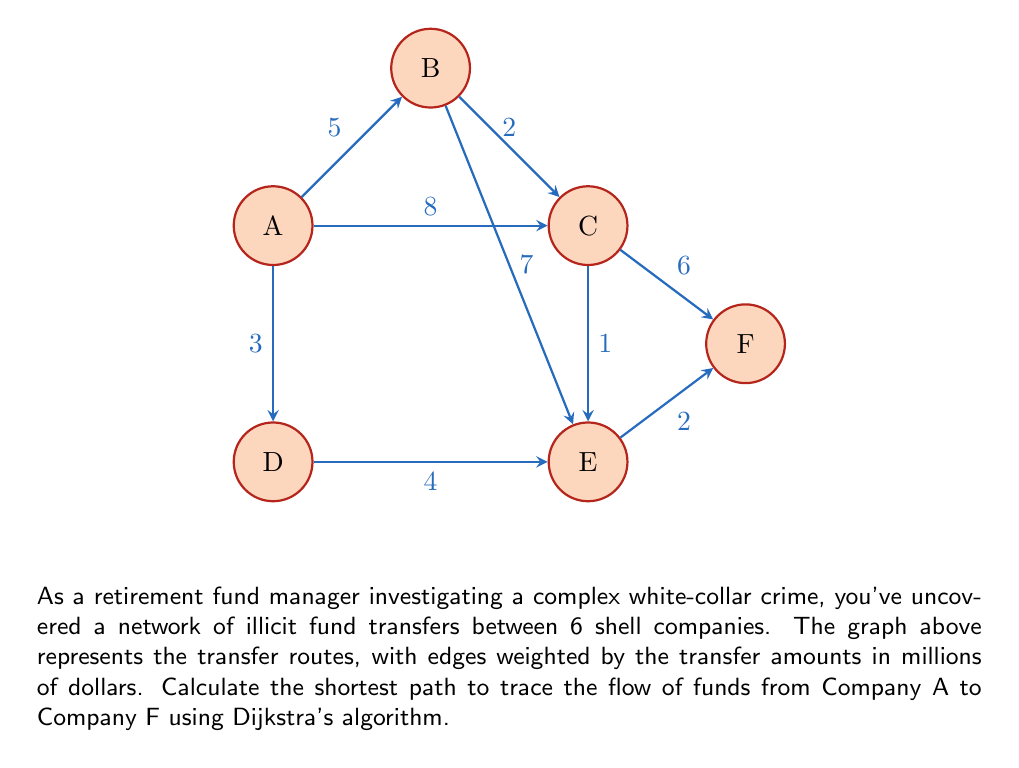Show me your answer to this math problem. To solve this problem, we'll use Dijkstra's algorithm to find the shortest path from Company A to Company F. Here's the step-by-step process:

1) Initialize:
   - Set distance to A as 0, and all others as infinity.
   - Set all nodes as unvisited.
   - Set A as the current node.

2) For the current node, calculate the distance to all unvisited neighbors:
   - A to B: 0 + 5 = 5
   - A to C: 0 + 8 = 8
   - A to D: 0 + 3 = 3

3) Update distances if shorter path found. Mark A as visited.

4) Select the unvisited node with the smallest distance (D) as the new current node.

5) Repeat steps 2-4:
   - From D: Update E to 7 (3 + 4)
   - From B: Update C to 7 (5 + 2), E to 12 (5 + 7)
   - From C: Update E to 8 (7 + 1), F to 13 (7 + 6)
   - From E: Update F to 10 (8 + 2)

6) The algorithm terminates when F is reached.

The shortest path is: A → D → E → F

The total distance (sum of transfer amounts) is:
$$ 3 + 4 + 2 = 9 \text{ million dollars} $$
Answer: A → D → E → F, $9 million 